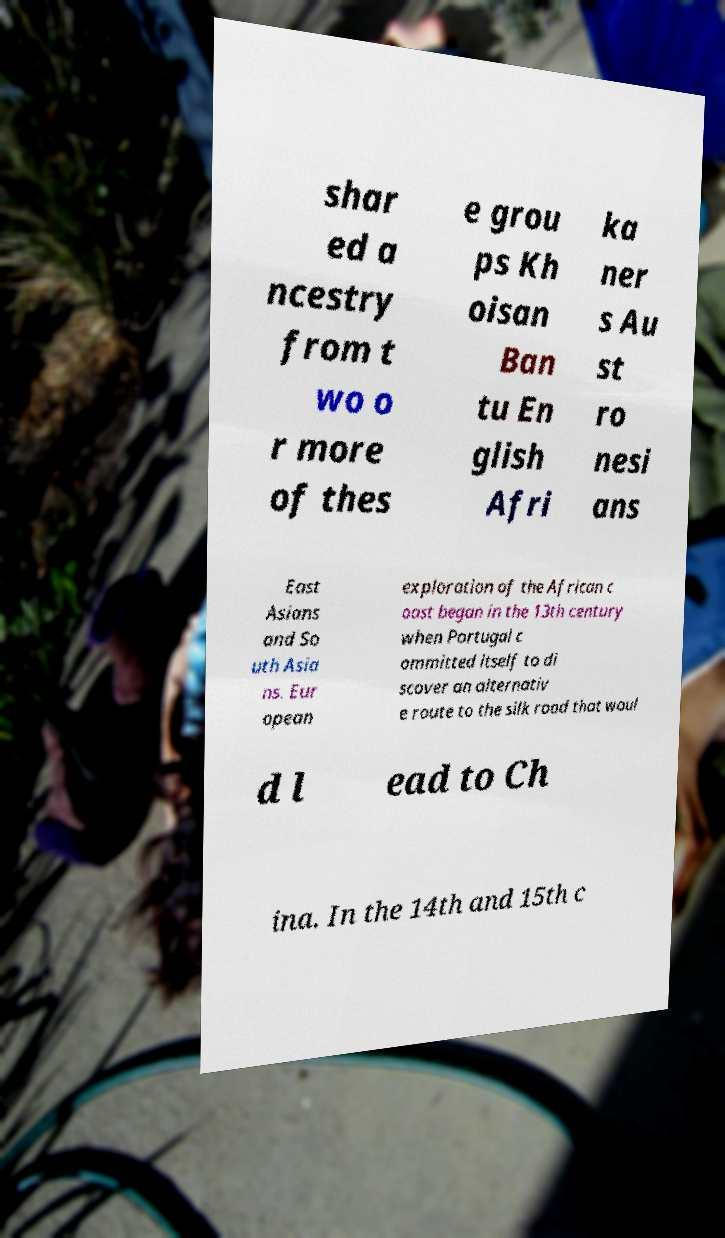There's text embedded in this image that I need extracted. Can you transcribe it verbatim? shar ed a ncestry from t wo o r more of thes e grou ps Kh oisan Ban tu En glish Afri ka ner s Au st ro nesi ans East Asians and So uth Asia ns. Eur opean exploration of the African c oast began in the 13th century when Portugal c ommitted itself to di scover an alternativ e route to the silk road that woul d l ead to Ch ina. In the 14th and 15th c 